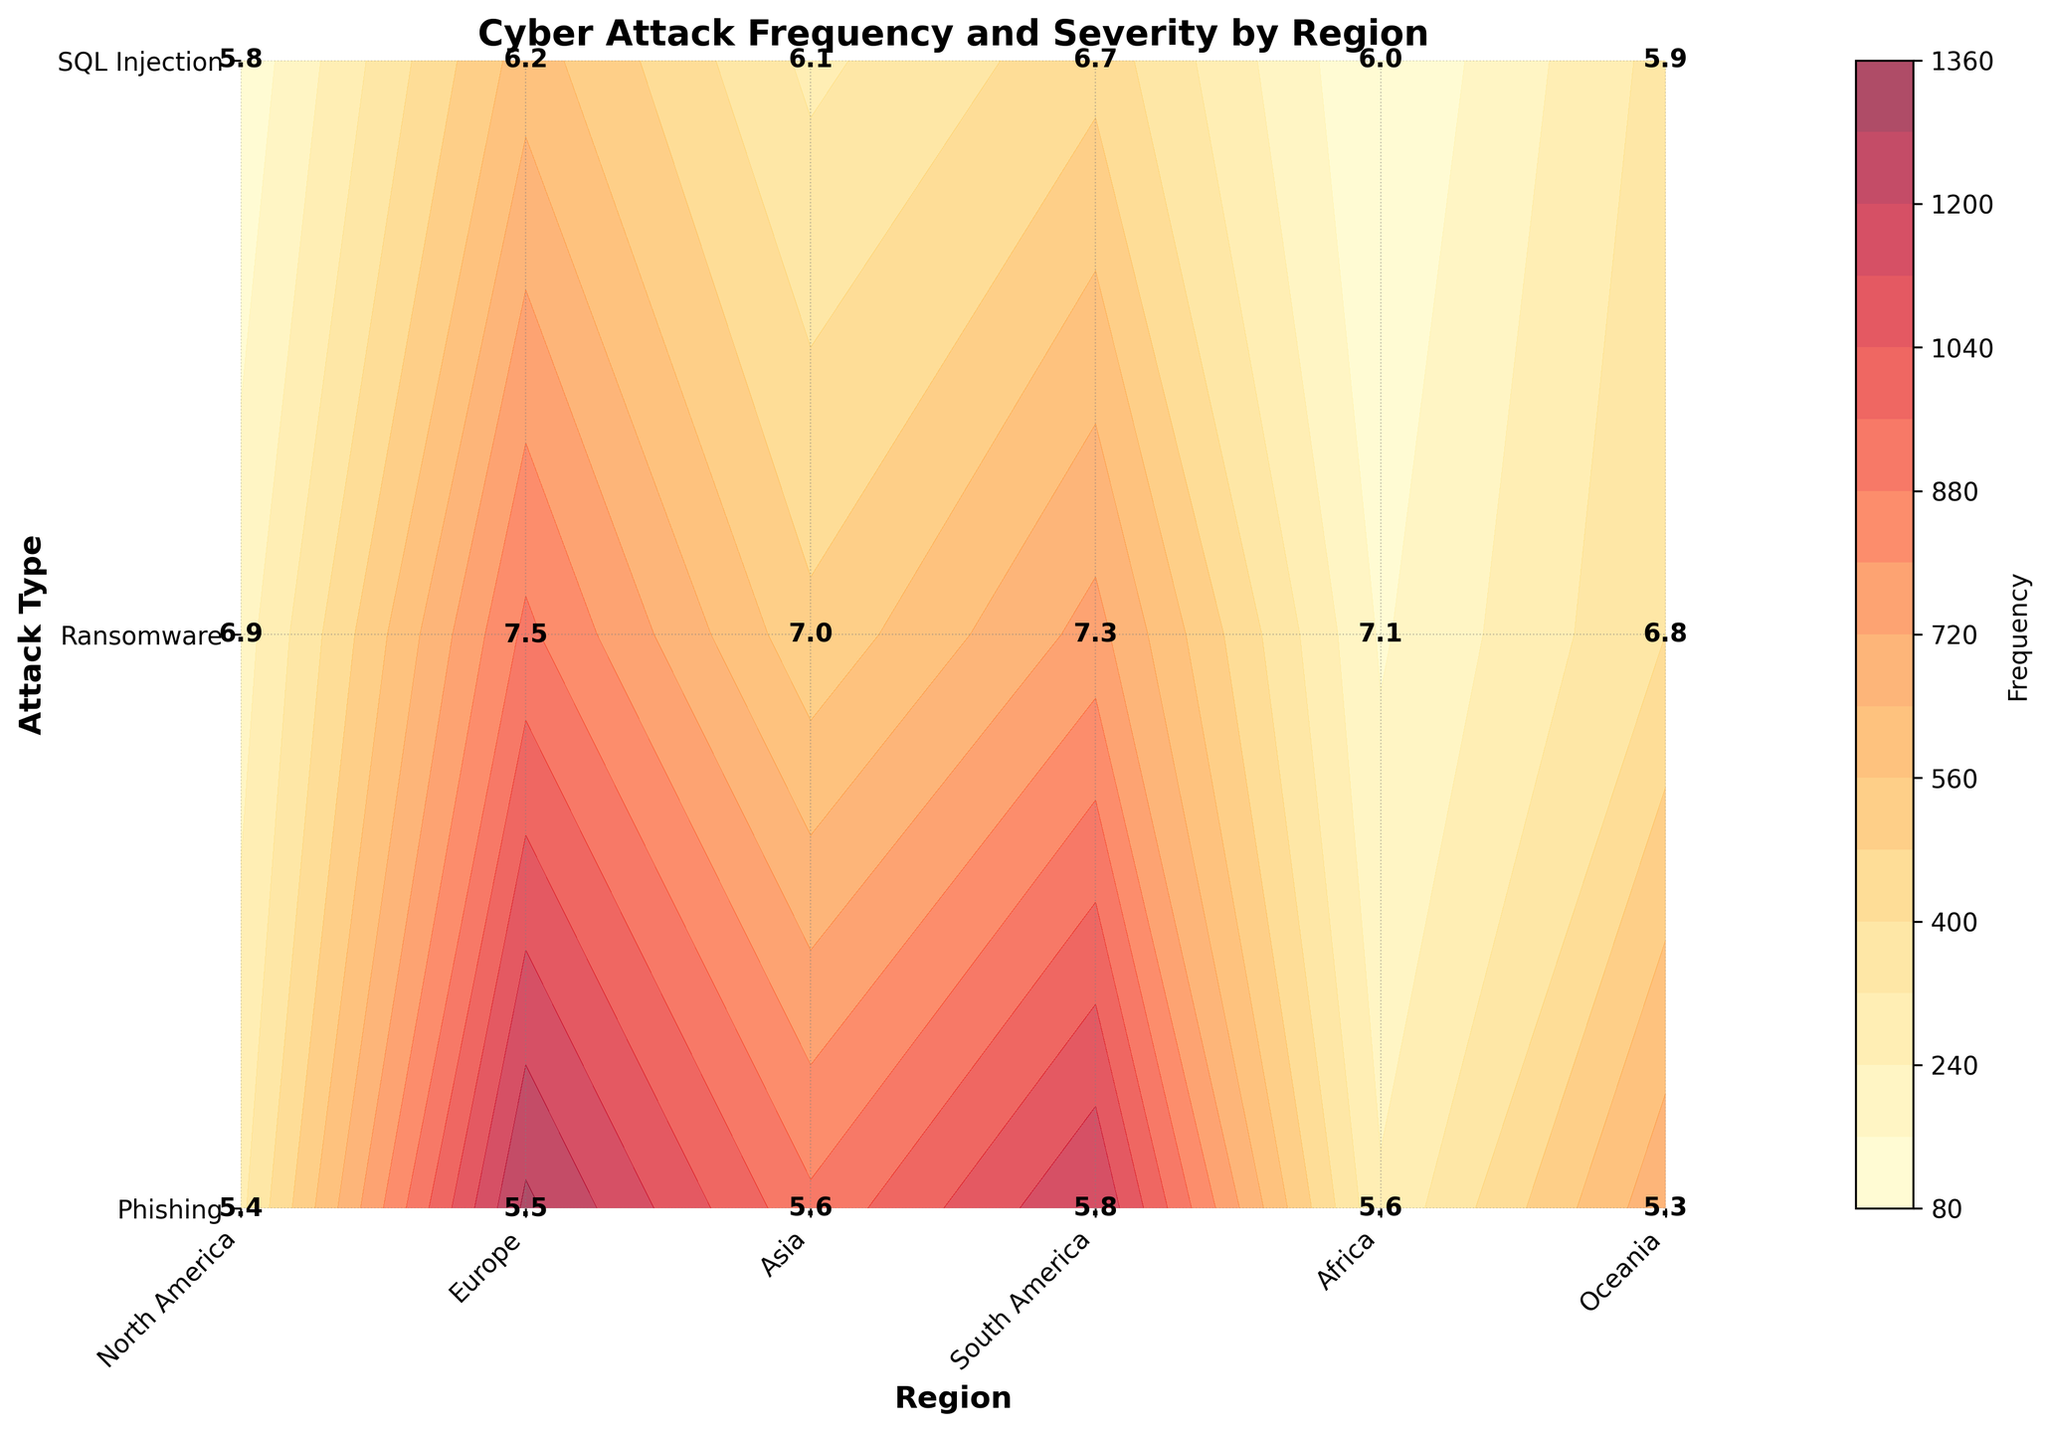What is the title of the figure? The title of the figure is displayed at the top, usually in bold, larger font, and provides the main topic covered by the chart.
Answer: Cyber Attack Frequency and Severity by Region Which region has the highest frequency of Phishing attacks? To find this, locate the row corresponding to Phishing. Identify the region on the x-axis with the highest contour level or frequency value and verify with labels.
Answer: Asia What is the severity level of Ransomware attacks in Europe? Find the cell where the Europe column intersects with the Ransomware row. The value within this cell represents the severity level of Ransomware attacks in Europe.
Answer: 7.0 Compare the frequency of SQL Injection attacks between North America and South America. Locate the SQL Injection row and compare the frequency values for North America and South America by looking at their respective contour levels and labels.
Answer: North America has a higher frequency (450 vs. 350) What is the average severity of Phishing attacks across all regions? Find all the severity values associated with Phishing attacks across regions (5.8, 5.6, 5.5, 5.3, 5.4, 5.6). Sum these values and divide by the number of regions to get the average.
Answer: 5.5 Which attack type in Africa has the lowest severity? Look at the severity values in the Africa column and identify the lowest value. Check the corresponding attack type.
Answer: SQL Injection Is the severity of Ransomware attacks universally higher than that of Phishing attacks across all regions? Compare the severity values of Ransomware and Phishing attacks for each region and determine if Ransomware has higher values consistently.
Answer: Yes What is the combined frequency of SQL Injection attacks in Asia and Europe? Identify the frequency values for SQL Injection in both Asia and Europe. Add these values together (600 + 300).
Answer: 900 Among the Ransomware attacks, which region has the least frequency? Locate the Ransomware row and identify the region on the x-axis with the lowest contour level or frequency value.
Answer: Oceania What pattern do you observe in the severity of Phishing attacks across regions? Observe the severity values of Phishing attacks across different regions and note any trend or consistency. All values are within a similar range, close to 5.5, indicating moderate severity levels generally.
Answer: Consistently moderate 